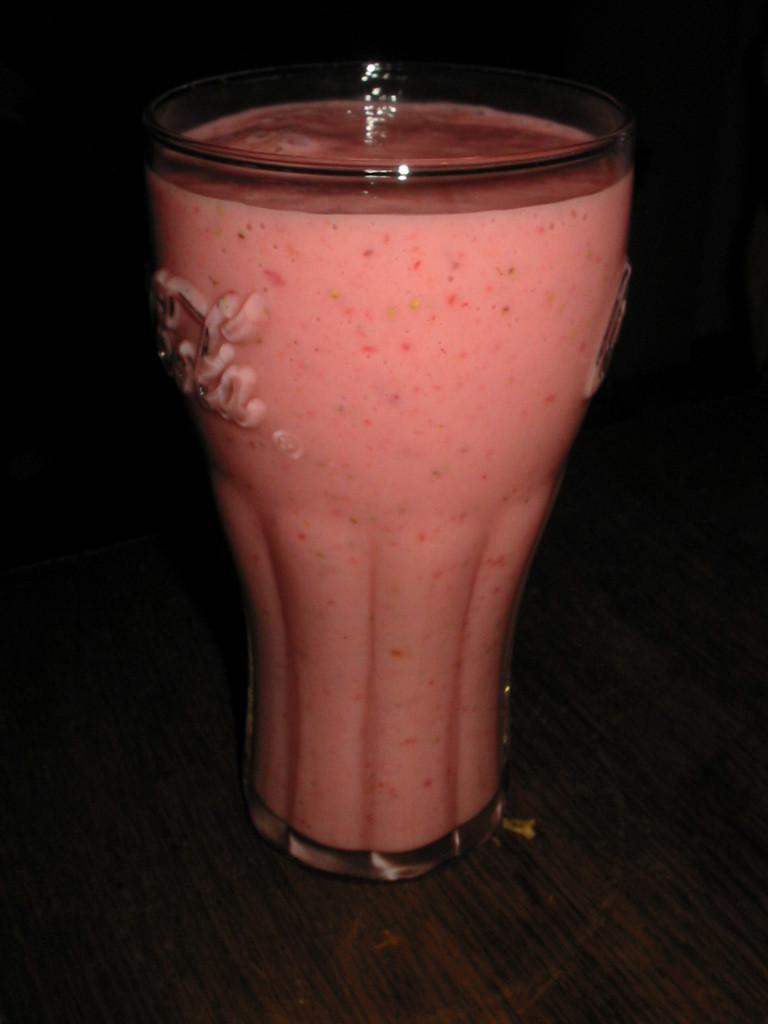In one or two sentences, can you explain what this image depicts? In this image we can see a glass filled with a liquid substance which is placed on the wooden surface. 